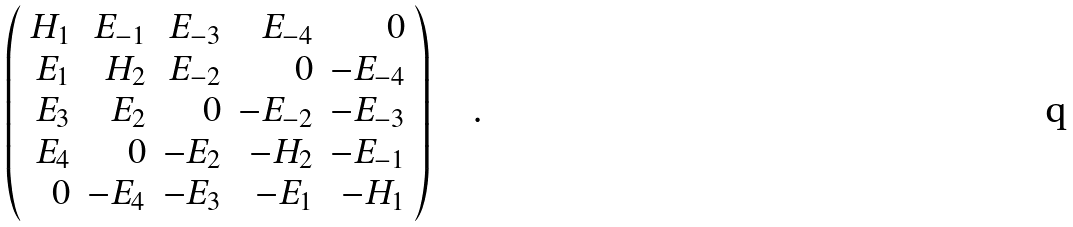Convert formula to latex. <formula><loc_0><loc_0><loc_500><loc_500>\left ( \begin{array} { r r r r r } H _ { 1 } & E _ { - 1 } & E _ { - 3 } & E _ { - 4 } & 0 \\ E _ { 1 } & H _ { 2 } & E _ { - 2 } & 0 & - E _ { - 4 } \\ E _ { 3 } & E _ { 2 } & 0 & - E _ { - 2 } & - E _ { - 3 } \\ E _ { 4 } & 0 & - E _ { 2 } & - H _ { 2 } & - E _ { - 1 } \\ 0 & - E _ { 4 } & - E _ { 3 } & - E _ { 1 } & - H _ { 1 } \end{array} \right ) \quad .</formula> 